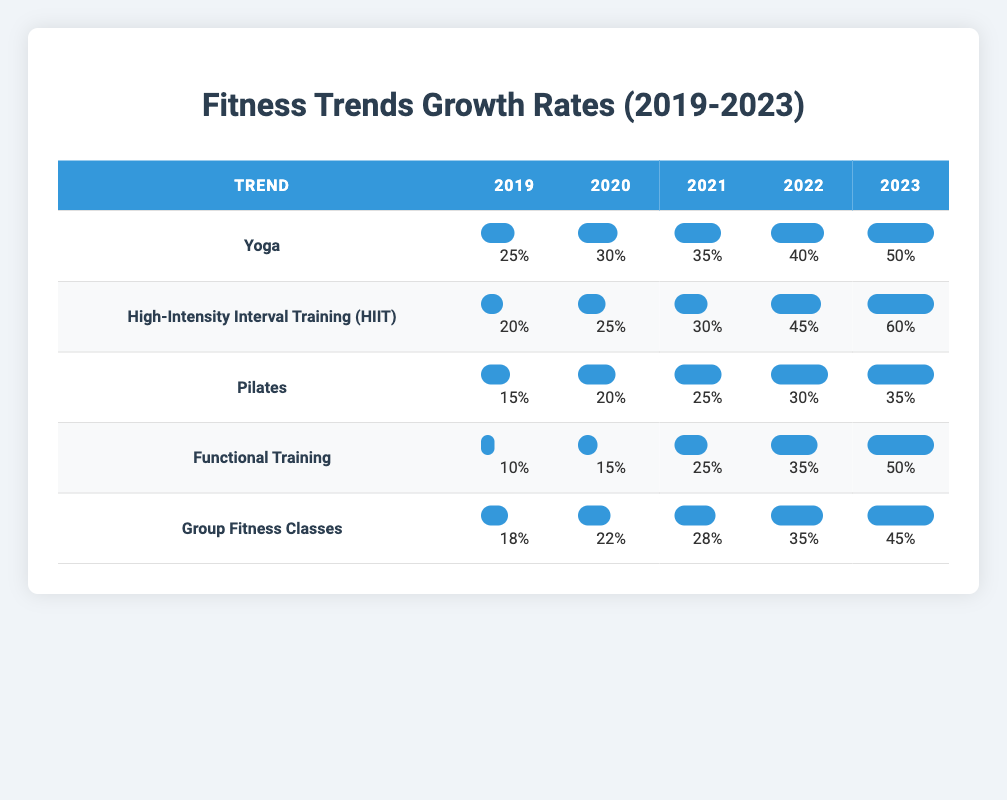What was the growth rate of Yoga in 2022? Looking at the row for Yoga, the value listed under the year 2022 is 40.
Answer: 40 Which fitness trend had the highest growth rate in 2023? In the year 2023, HIIT had the highest growth rate of 60, compared to the other trends listed.
Answer: HIIT What is the total growth rate for Functional Training from 2019 to 2023? Summing the values from 2019 to 2023 gives us 10 + 15 + 25 + 35 + 50 = 135.
Answer: 135 Is it true that Pilates had a higher growth rate than Group Fitness Classes in 2021? In 2021, Pilates had a growth rate of 25 while Group Fitness Classes had a rate of 28, so this statement is false.
Answer: No What was the average growth rate for Group Fitness Classes over the years? The growth rates for Group Fitness Classes are 18, 22, 28, 35, and 45. The sum is 18 + 22 + 28 + 35 + 45 = 148. There are 5 data points, so the average is 148 / 5 = 29.6.
Answer: 29.6 How much did the growth rate of HIIT increase from 2019 to 2023? The growth rate of HIIT in 2019 was 20 and in 2023 it was 60. The increase is calculated as 60 - 20 = 40.
Answer: 40 Did any fitness trend have a consistent growth rate every year from 2019 to 2023? By examining each year's data for all trends, it shows that none of the trends maintained a consistent growth rate, as they all fluctuate each year.
Answer: No What is the difference between the growth rates of Yoga and Pilates in 2023? In 2023, the growth rate for Yoga is 50 and for Pilates, it is 35. The difference is calculated as 50 - 35 = 15.
Answer: 15 